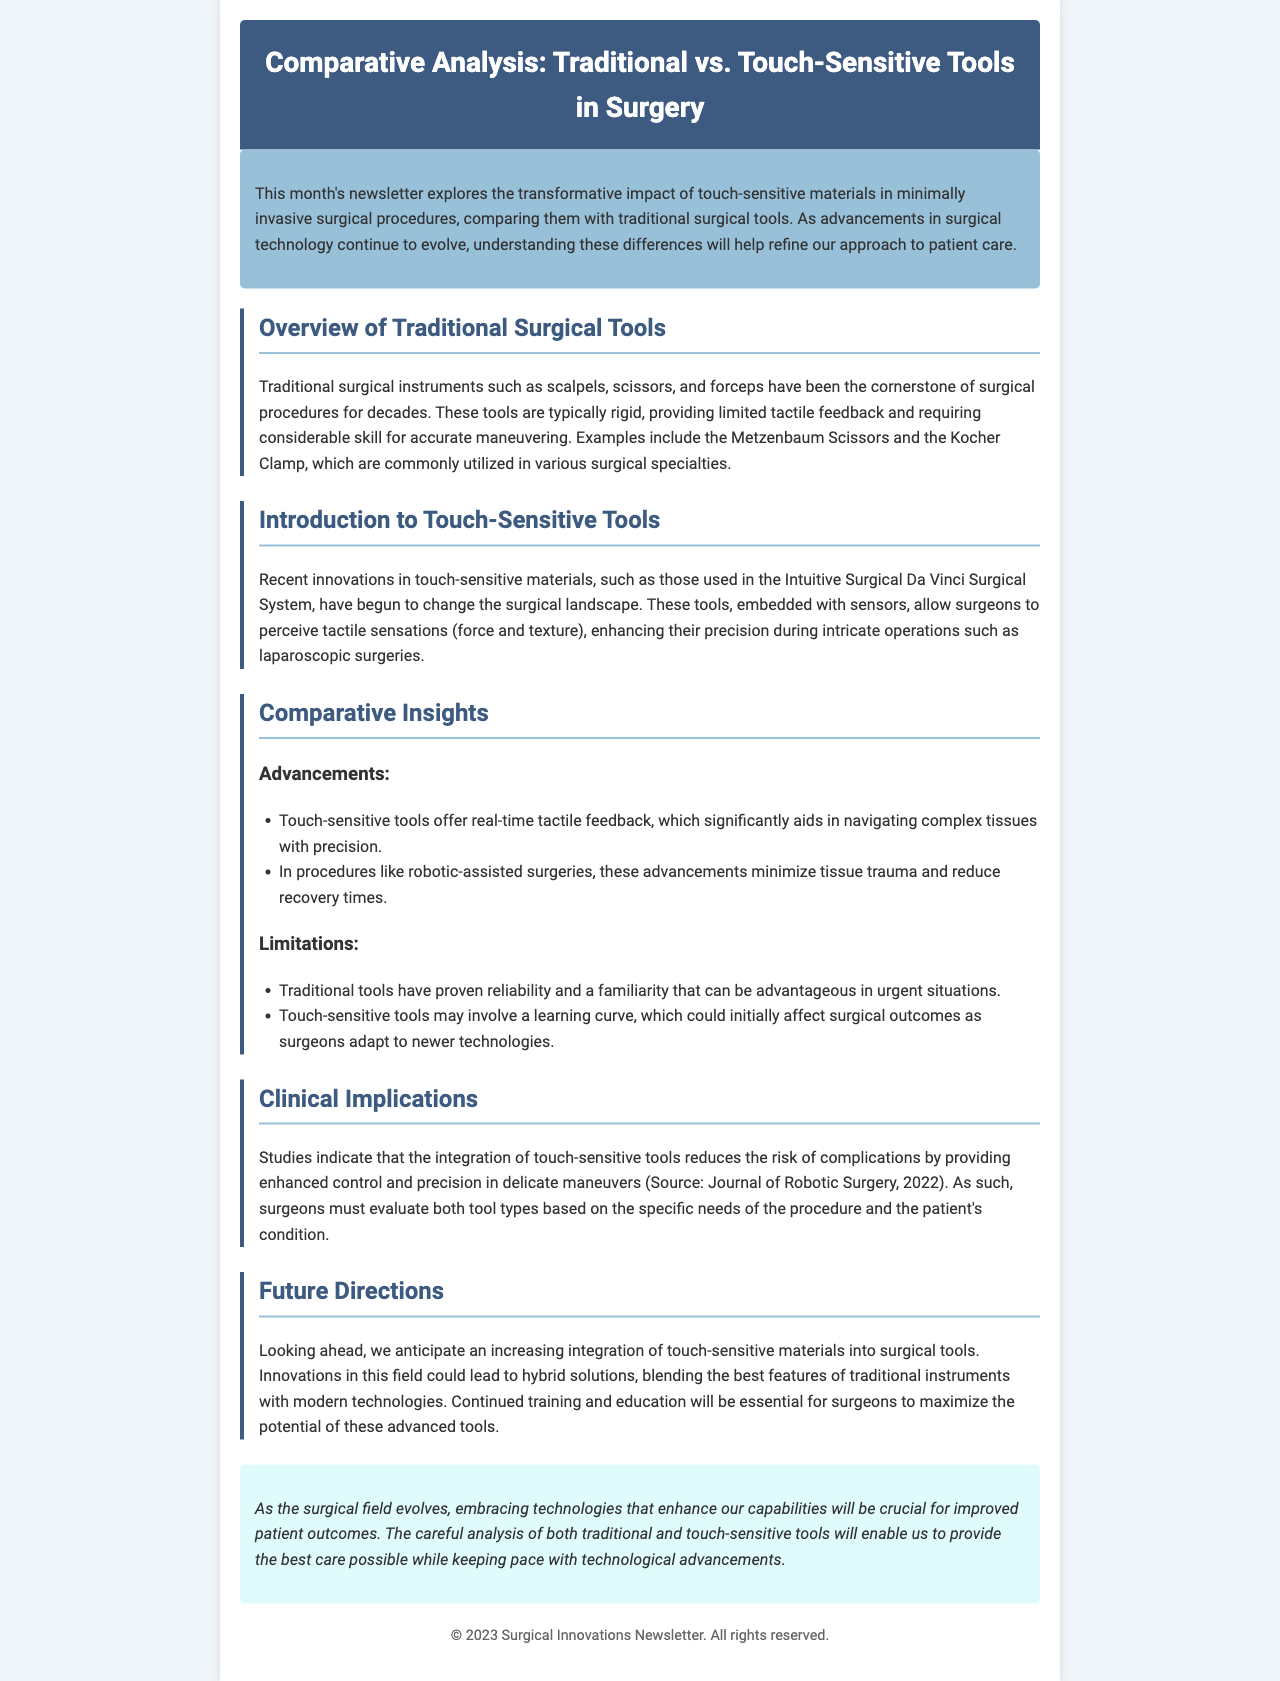What is the title of the newsletter? The title can be found in the header of the document, which states "Comparative Analysis: Traditional vs. Touch-Sensitive Tools in Surgery."
Answer: Comparative Analysis: Traditional vs. Touch-Sensitive Tools in Surgery What recent system is mentioned in relation to touch-sensitive tools? The document introduces the "Intuitive Surgical Da Vinci Surgical System" as an example of the use of touch-sensitive materials.
Answer: Intuitive Surgical Da Vinci Surgical System What is one advantage of touch-sensitive tools mentioned? The newsletter highlights that touch-sensitive tools provide "real-time tactile feedback," which is a significant advancement in surgery.
Answer: real-time tactile feedback Which surgical specialty commonly utilizes Metzenbaum Scissors? The document does not specify a specialty but states that Metzenbaum Scissors are commonly utilized in various surgical specialties.
Answer: various surgical specialties What is a limitation of touch-sensitive tools? The newsletter mentions that touch-sensitive tools may involve "a learning curve," affecting surgical outcomes initially.
Answer: a learning curve What is a potential future direction for surgical tools? The document suggests that "hybrid solutions" could be developed, combining traditional instruments with modern technologies.
Answer: hybrid solutions What year is cited for the source on clinical implications? The document refers to a study published in "2022" in the Journal of Robotic Surgery related to the benefits of touch-sensitive tools.
Answer: 2022 What is the concluding sentiment expressed in the newsletter? The conclusion emphasizes the importance of embracing new technologies for improved patient outcomes.
Answer: improved patient outcomes 